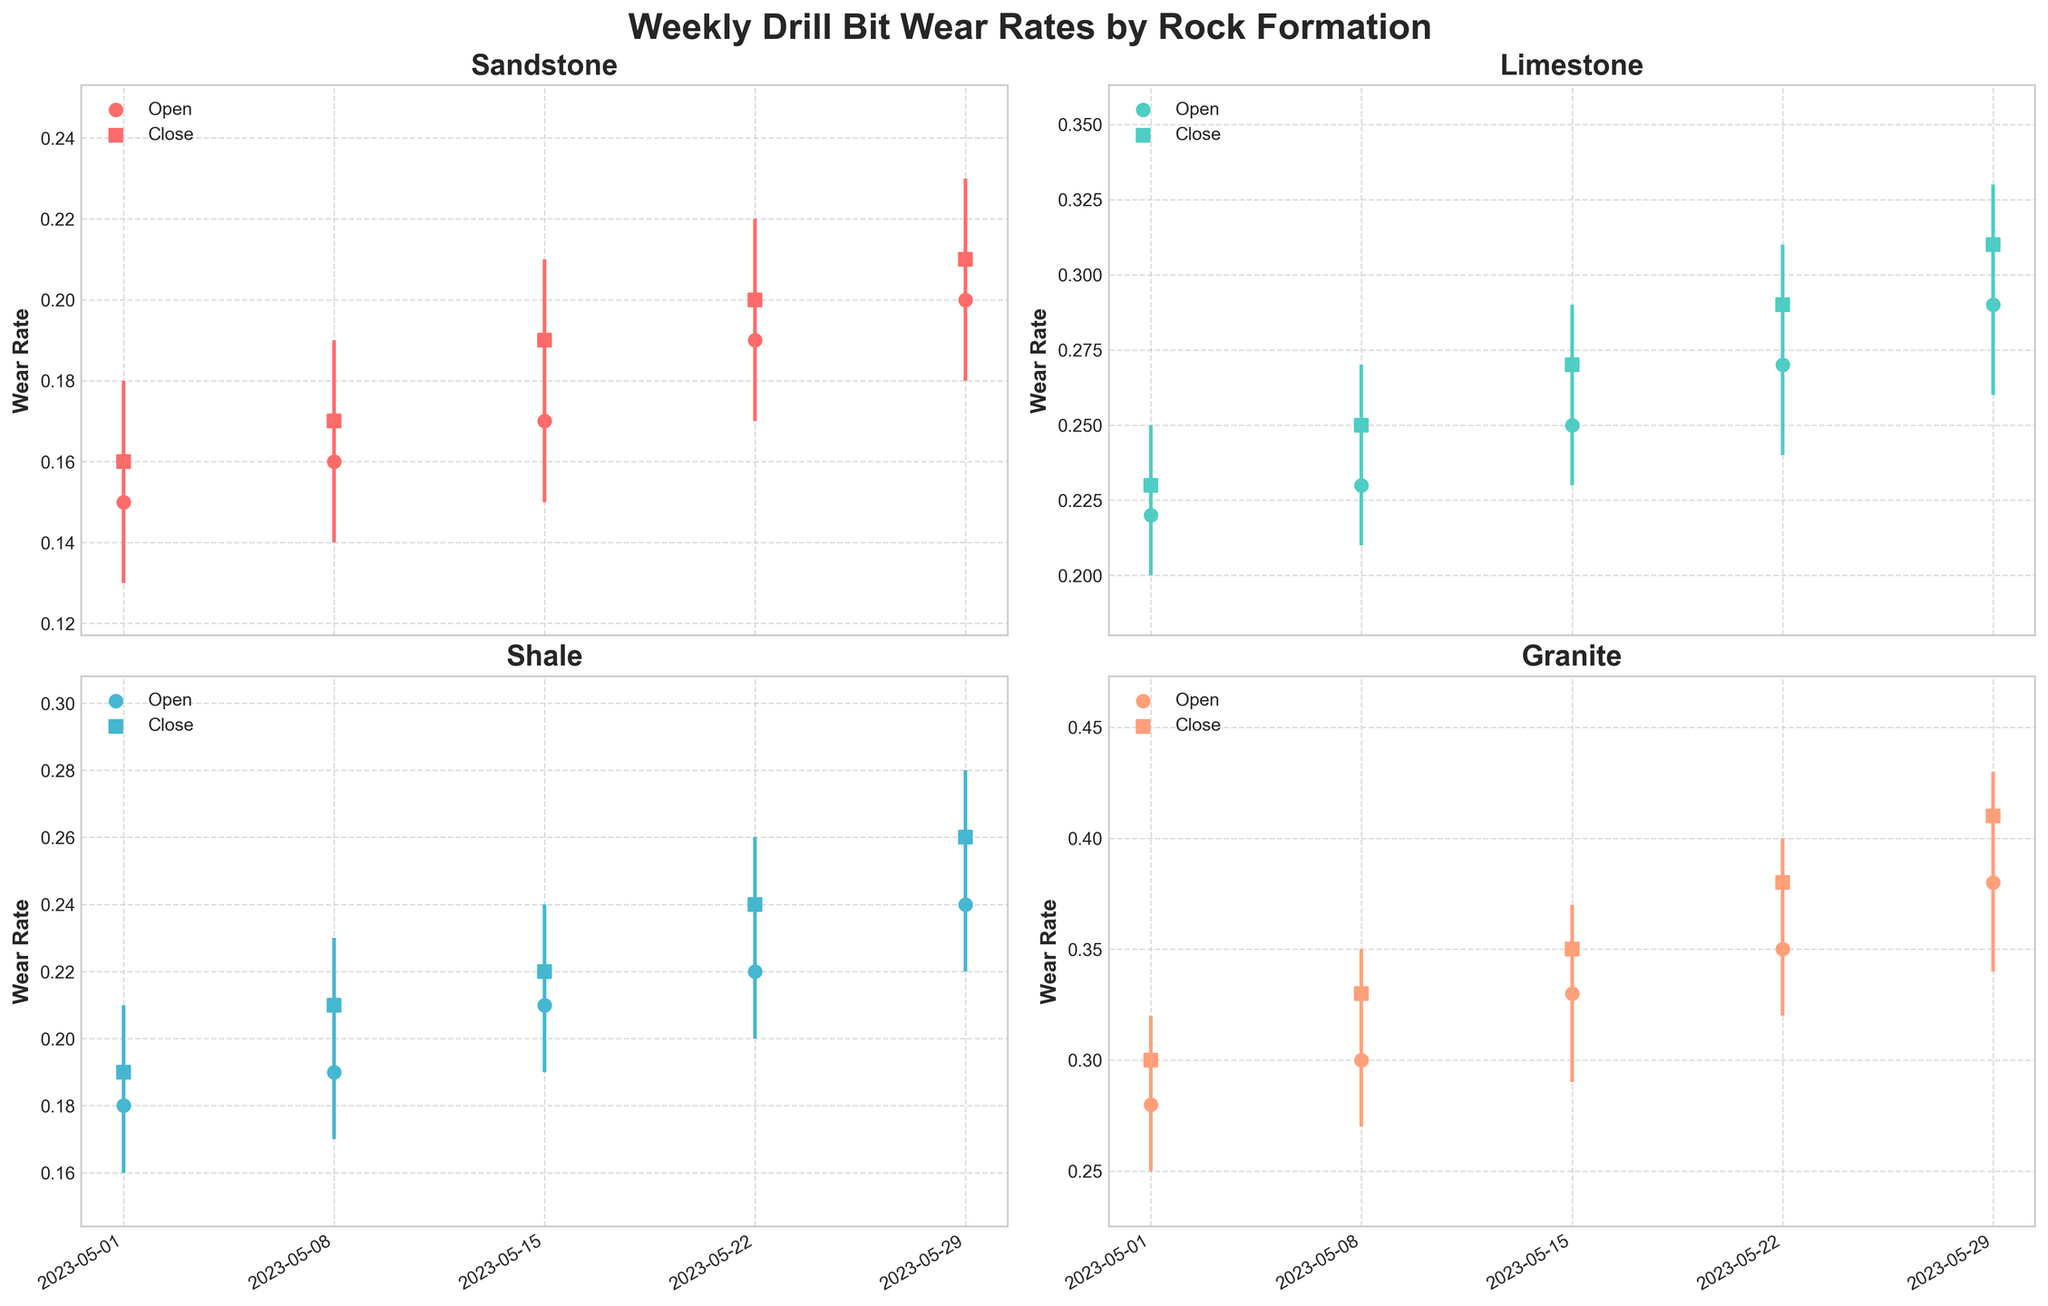How many weeks of data are displayed in the chart? The x-axis shows weekly data points for each rock formation. By counting the data points for one formation, we can see there are 5 weeks of data displayed in the chart.
Answer: 5 Which rock formation has the highest overall wear rate by the end of May? To determine the highest overall wear rate, check the closing values on May 29 for all formations. Granite has the highest value of 0.41 by the end of May.
Answer: Granite What is the range of wear rates for Shale on the week of May 22? The range is calculated by subtracting the lowest value from the highest value for the given week. For the week of May 22 in Shale, the high is 0.26 and the low is 0.20, so the range is 0.26 - 0.20 = 0.06.
Answer: 0.06 On which week did Sandstone experience the highest increase in wear rate? Look at the difference between the closing and opening values for each week. The highest increase was from May 15 to May 22, where the wear rate increased from 0.19 to 0.20. An increase of 0.01 is the largest weekly increase for Sandstone.
Answer: May 22 Compare the wear rates between Sandstone and Limestone for the first week of May. Which one is higher? Check the closing values for both Sandstone and Limestone on May 1. Sandstone closed at 0.16, and Limestone closed at 0.23. Therefore, Limestone has a higher wear rate.
Answer: Limestone What is the average closing wear rate for Granite during the month of May? To find the average, sum the closing rates for each week and divide by the number of weeks. The closing rates are 0.30, 0.33, 0.35, 0.38, and 0.41. The sum is 1.77, and the average is 1.77 / 5 = 0.354.
Answer: 0.354 Identify the week and rock formation with the maximum single week wear rate change. To find the maximum change within a single week, look at the difference between high and low values. For Granite in the week of May 8, the difference is 0.35 - 0.27 = 0.08, which is the highest single week change.
Answer: Granite in the week of May 8 Between which two consecutive weeks did Limestone have the largest increase in closing wear rate? Calculate the difference in closing wear rates between consecutive weeks. For Limestone: May 1 to May 8 (0.25 - 0.23 = 0.02), May 8 to May 15 (0.27 - 0.25 = 0.02), May 15 to May 22 (0.29 - 0.27 = 0.02), May 22 to May 29 (0.31 - 0.29 = 0.02). Each increase is 0.02, making them all equal.
Answer: All consecutive weeks have equal increases 